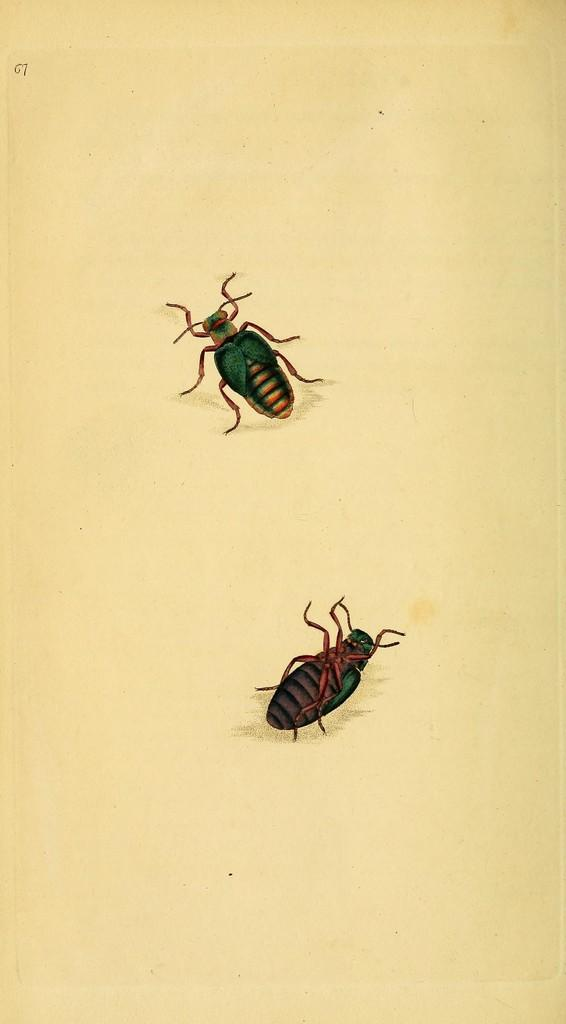What is the main subject of the image? The main subject of the image is a picture of insects. What type of dress is the insect wearing in the image? Insects do not wear dresses, as they are not human and do not have the ability to wear clothing. 